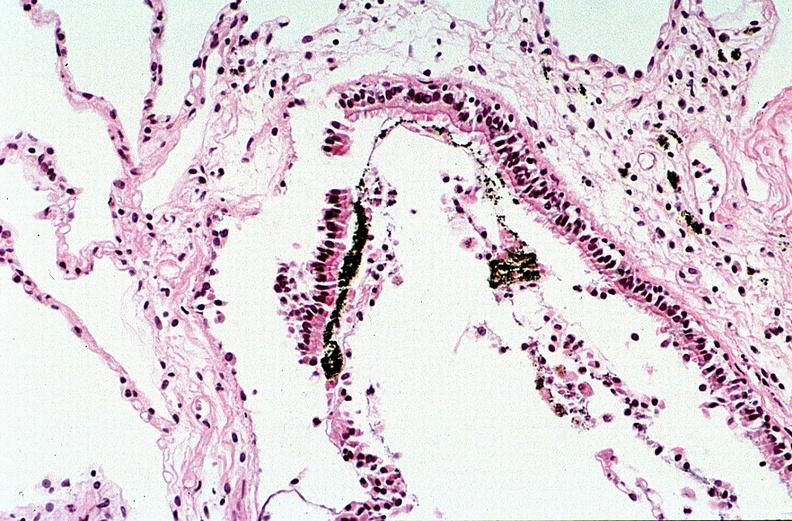does this image show thermal burn?
Answer the question using a single word or phrase. Yes 